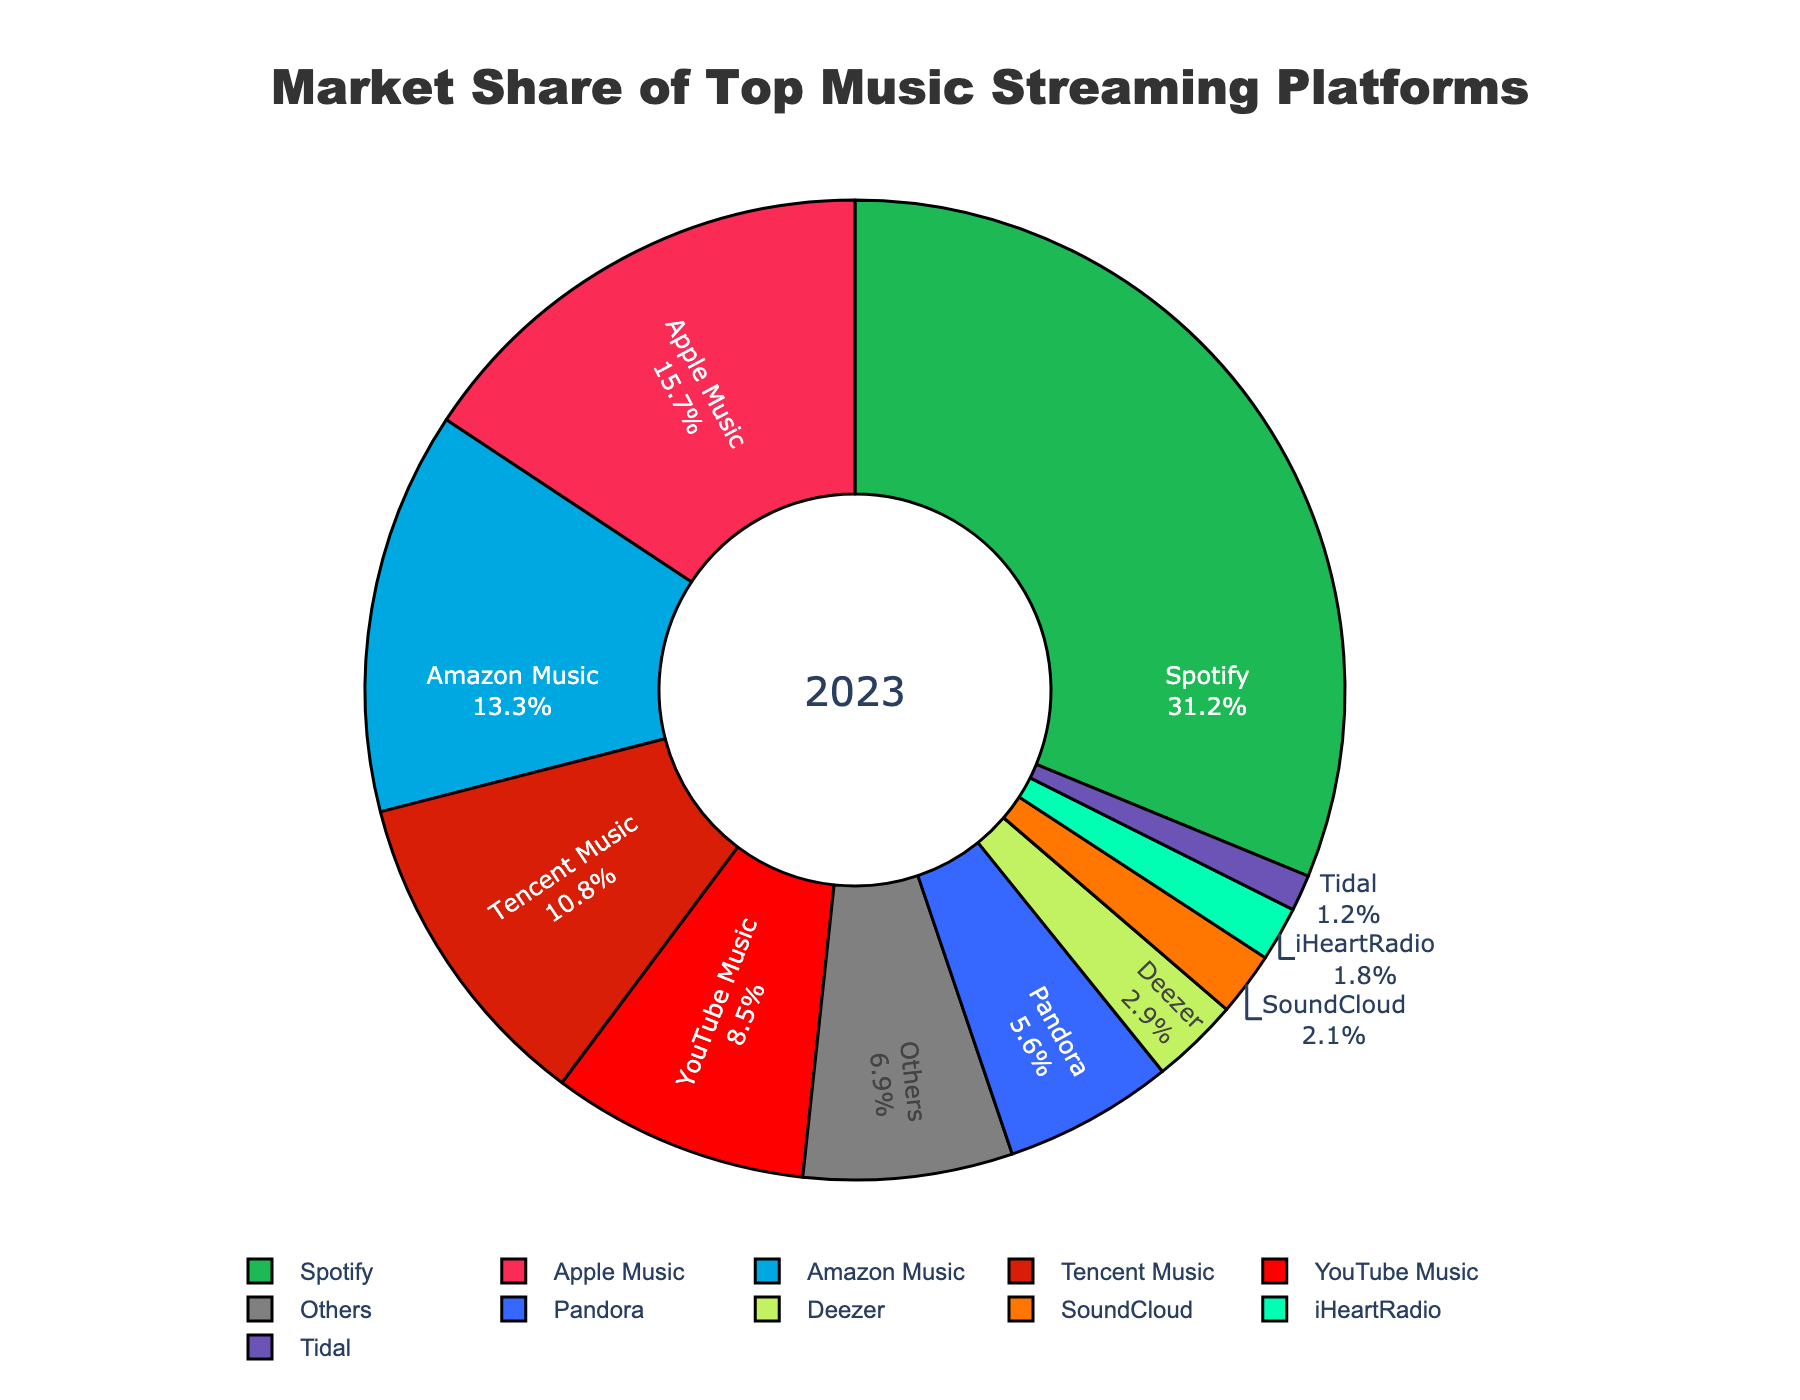What percentage of the market is controlled by Spotify and Apple Music combined? To determine the combined market share of Spotify and Apple Music, add the respective percentages: 31.2% (Spotify) + 15.7% (Apple Music) = 46.9%.
Answer: 46.9% Which platform has a slightly higher market share, Amazon Music or Tencent Music? Compare the market share percentages of Amazon Music (13.3%) and Tencent Music (10.8%). Amazon Music has a higher market share.
Answer: Amazon Music What is the total market share of platforms with less than 3% market share each? Identify platforms with less than 3% market share (Deezer, SoundCloud, iHeartRadio, Tidal), then add their percentages: 2.9% + 2.1% + 1.8% + 1.2% = 8%.
Answer: 8% Which platform has the smallest market share, and what is that percentage? Identify the platform with the lowest market share, which is Tidal at 1.2%.
Answer: Tidal, 1.2% How does the market share of YouTube Music compare to Pandora? Compare the market shares of YouTube Music (8.5%) and Pandora (5.6%). YouTube Music has a higher market share.
Answer: YouTube Music What is the market share difference between the most popular and the least popular platform? Subtract the market share of the least popular platform (Tidal at 1.2%) from the most popular platform (Spotify at 31.2%): 31.2% - 1.2% = 30%.
Answer: 30% If the "Others" category were a single platform, how would its market share rank relative to other platforms? "Others" has a market share of 6.9%. Rank it among the given platforms: it would be higher than Deezer (2.9%) but lower than Pandora (5.6%), so it would rank after Pandora and before Deezer.
Answer: Between Pandora and Deezer Which has a larger market share, the combination of Amazon Music and YouTube Music or the combination of Apple Music and Tencent Music? Sum the market shares of each combination: Amazon Music (13.3%) + YouTube Music (8.5%) = 21.8%; Apple Music (15.7%) + Tencent Music (10.8%) = 26.5%. Apple Music and Tencent Music combined have a larger market share.
Answer: Apple Music and Tencent Music What percentage of the market is controlled by Spotify, Apple Music, and Amazon Music in total? Add the market shares of Spotify (31.2%), Apple Music (15.7%), and Amazon Music (13.3%): 31.2% + 15.7% + 13.3% = 60.2%.
Answer: 60.2% Considering the top five platforms only, what is their combined market share? Add the market shares of the top five platforms: Spotify (31.2%), Apple Music (15.7%), Amazon Music (13.3%), Tencent Music (10.8%), and YouTube Music (8.5%): 31.2% + 15.7% + 13.3% + 10.8% + 8.5% = 79.5%.
Answer: 79.5% 